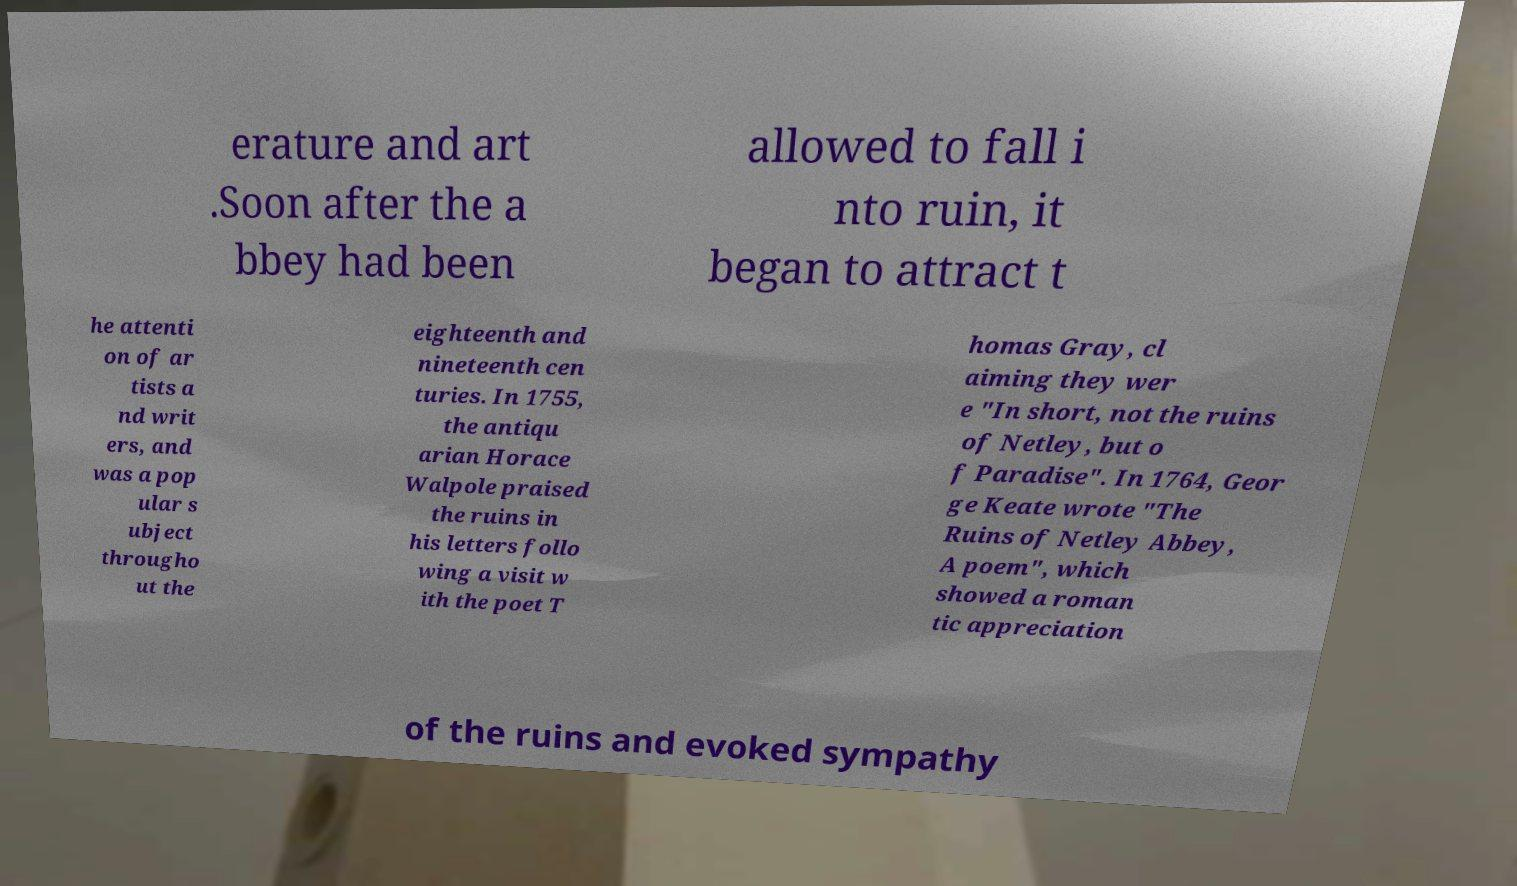Could you assist in decoding the text presented in this image and type it out clearly? erature and art .Soon after the a bbey had been allowed to fall i nto ruin, it began to attract t he attenti on of ar tists a nd writ ers, and was a pop ular s ubject througho ut the eighteenth and nineteenth cen turies. In 1755, the antiqu arian Horace Walpole praised the ruins in his letters follo wing a visit w ith the poet T homas Gray, cl aiming they wer e "In short, not the ruins of Netley, but o f Paradise". In 1764, Geor ge Keate wrote "The Ruins of Netley Abbey, A poem", which showed a roman tic appreciation of the ruins and evoked sympathy 